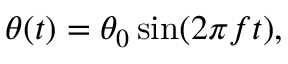Convert formula to latex. <formula><loc_0><loc_0><loc_500><loc_500>\begin{array} { r } { \theta ( t ) = \theta _ { 0 } \sin ( 2 \pi f t ) , } \end{array}</formula> 